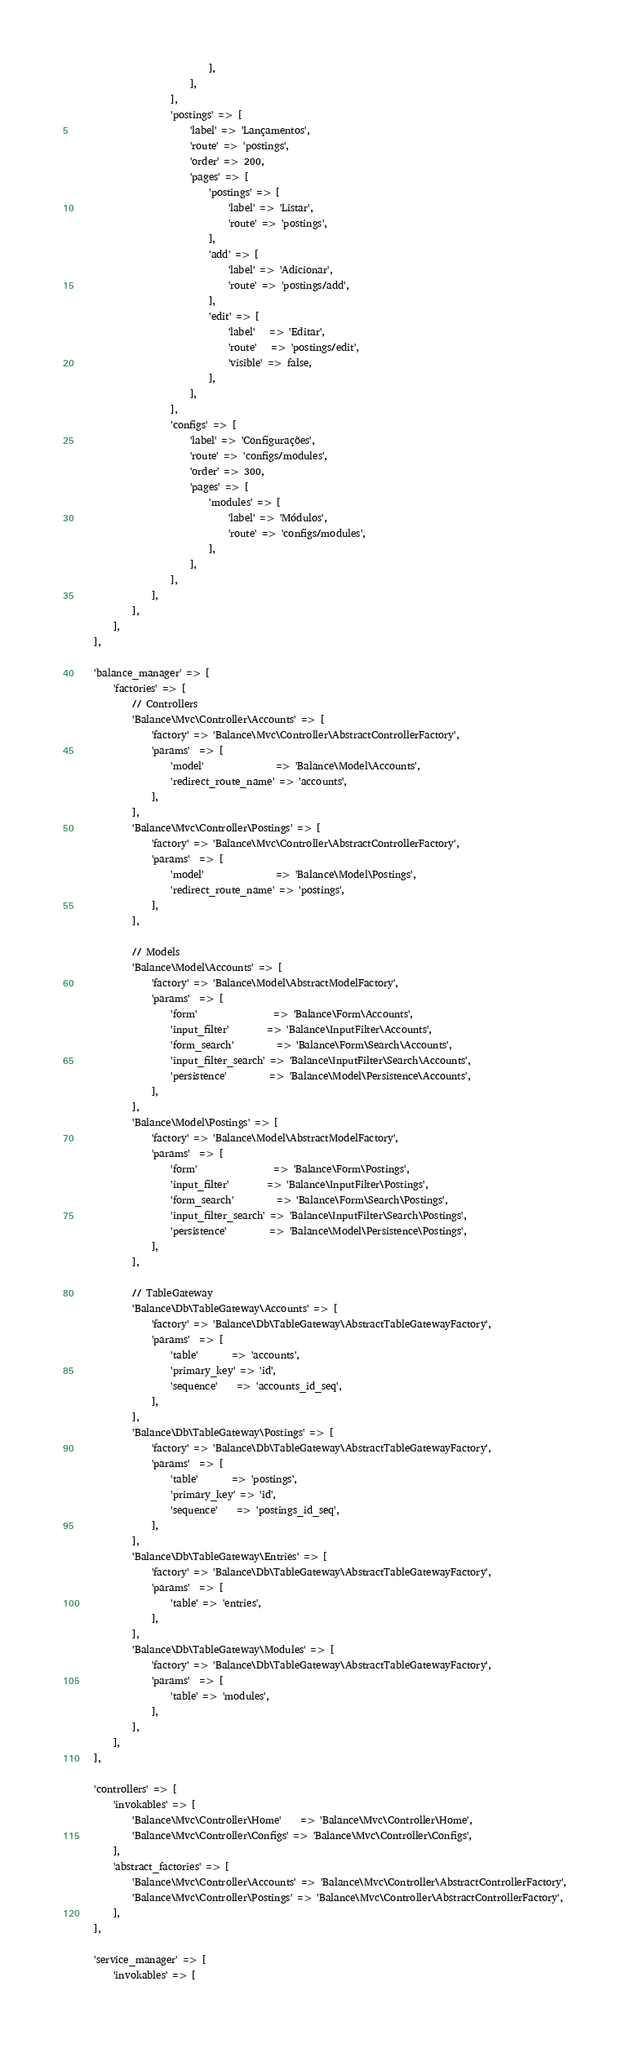<code> <loc_0><loc_0><loc_500><loc_500><_PHP_>                            ],
                        ],
                    ],
                    'postings' => [
                        'label' => 'Lançamentos',
                        'route' => 'postings',
                        'order' => 200,
                        'pages' => [
                            'postings' => [
                                'label' => 'Listar',
                                'route' => 'postings',
                            ],
                            'add' => [
                                'label' => 'Adicionar',
                                'route' => 'postings/add',
                            ],
                            'edit' => [
                                'label'   => 'Editar',
                                'route'   => 'postings/edit',
                                'visible' => false,
                            ],
                        ],
                    ],
                    'configs' => [
                        'label' => 'Configurações',
                        'route' => 'configs/modules',
                        'order' => 300,
                        'pages' => [
                            'modules' => [
                                'label' => 'Módulos',
                                'route' => 'configs/modules',
                            ],
                        ],
                    ],
                ],
            ],
        ],
    ],

    'balance_manager' => [
        'factories' => [
            // Controllers
            'Balance\Mvc\Controller\Accounts' => [
                'factory' => 'Balance\Mvc\Controller\AbstractControllerFactory',
                'params'  => [
                    'model'               => 'Balance\Model\Accounts',
                    'redirect_route_name' => 'accounts',
                ],
            ],
            'Balance\Mvc\Controller\Postings' => [
                'factory' => 'Balance\Mvc\Controller\AbstractControllerFactory',
                'params'  => [
                    'model'               => 'Balance\Model\Postings',
                    'redirect_route_name' => 'postings',
                ],
            ],

            // Models
            'Balance\Model\Accounts' => [
                'factory' => 'Balance\Model\AbstractModelFactory',
                'params'  => [
                    'form'                => 'Balance\Form\Accounts',
                    'input_filter'        => 'Balance\InputFilter\Accounts',
                    'form_search'         => 'Balance\Form\Search\Accounts',
                    'input_filter_search' => 'Balance\InputFilter\Search\Accounts',
                    'persistence'         => 'Balance\Model\Persistence\Accounts',
                ],
            ],
            'Balance\Model\Postings' => [
                'factory' => 'Balance\Model\AbstractModelFactory',
                'params'  => [
                    'form'                => 'Balance\Form\Postings',
                    'input_filter'        => 'Balance\InputFilter\Postings',
                    'form_search'         => 'Balance\Form\Search\Postings',
                    'input_filter_search' => 'Balance\InputFilter\Search\Postings',
                    'persistence'         => 'Balance\Model\Persistence\Postings',
                ],
            ],

            // TableGateway
            'Balance\Db\TableGateway\Accounts' => [
                'factory' => 'Balance\Db\TableGateway\AbstractTableGatewayFactory',
                'params'  => [
                    'table'       => 'accounts',
                    'primary_key' => 'id',
                    'sequence'    => 'accounts_id_seq',
                ],
            ],
            'Balance\Db\TableGateway\Postings' => [
                'factory' => 'Balance\Db\TableGateway\AbstractTableGatewayFactory',
                'params'  => [
                    'table'       => 'postings',
                    'primary_key' => 'id',
                    'sequence'    => 'postings_id_seq',
                ],
            ],
            'Balance\Db\TableGateway\Entries' => [
                'factory' => 'Balance\Db\TableGateway\AbstractTableGatewayFactory',
                'params'  => [
                    'table' => 'entries',
                ],
            ],
            'Balance\Db\TableGateway\Modules' => [
                'factory' => 'Balance\Db\TableGateway\AbstractTableGatewayFactory',
                'params'  => [
                    'table' => 'modules',
                ],
            ],
        ],
    ],

    'controllers' => [
        'invokables' => [
            'Balance\Mvc\Controller\Home'    => 'Balance\Mvc\Controller\Home',
            'Balance\Mvc\Controller\Configs' => 'Balance\Mvc\Controller\Configs',
        ],
        'abstract_factories' => [
            'Balance\Mvc\Controller\Accounts' => 'Balance\Mvc\Controller\AbstractControllerFactory',
            'Balance\Mvc\Controller\Postings' => 'Balance\Mvc\Controller\AbstractControllerFactory',
        ],
    ],

    'service_manager' => [
        'invokables' => [</code> 